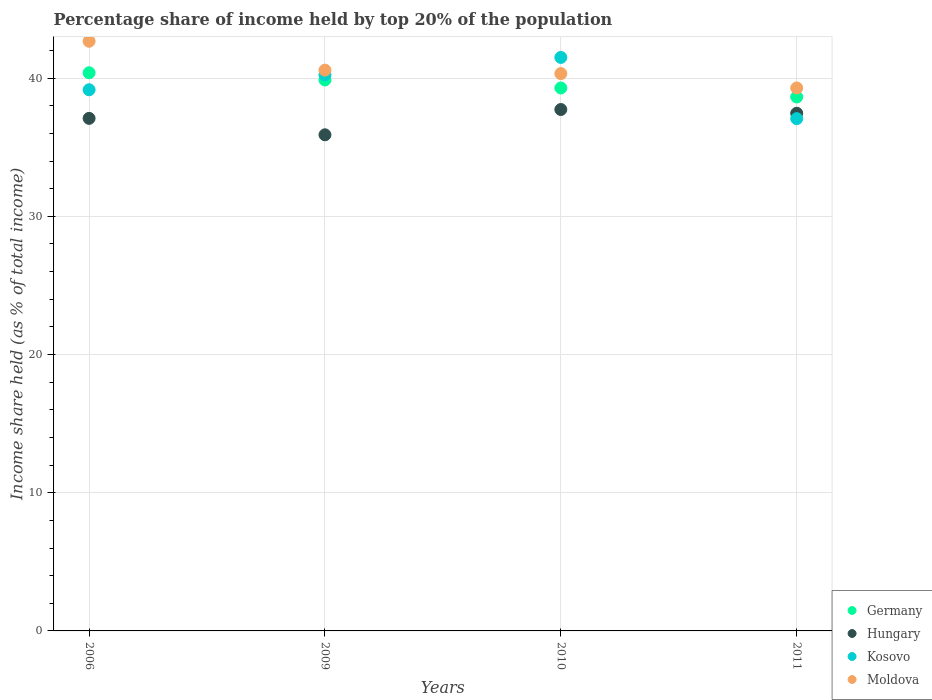Is the number of dotlines equal to the number of legend labels?
Your response must be concise. Yes. What is the percentage share of income held by top 20% of the population in Moldova in 2006?
Ensure brevity in your answer.  42.67. Across all years, what is the maximum percentage share of income held by top 20% of the population in Kosovo?
Provide a short and direct response. 41.5. Across all years, what is the minimum percentage share of income held by top 20% of the population in Germany?
Your answer should be very brief. 38.64. In which year was the percentage share of income held by top 20% of the population in Hungary maximum?
Offer a very short reply. 2010. What is the total percentage share of income held by top 20% of the population in Moldova in the graph?
Ensure brevity in your answer.  162.87. What is the difference between the percentage share of income held by top 20% of the population in Moldova in 2010 and that in 2011?
Provide a succinct answer. 1.04. What is the difference between the percentage share of income held by top 20% of the population in Germany in 2011 and the percentage share of income held by top 20% of the population in Hungary in 2010?
Offer a very short reply. 0.91. What is the average percentage share of income held by top 20% of the population in Moldova per year?
Your answer should be very brief. 40.72. In the year 2011, what is the difference between the percentage share of income held by top 20% of the population in Moldova and percentage share of income held by top 20% of the population in Kosovo?
Offer a very short reply. 2.22. In how many years, is the percentage share of income held by top 20% of the population in Hungary greater than 8 %?
Provide a succinct answer. 4. What is the ratio of the percentage share of income held by top 20% of the population in Germany in 2010 to that in 2011?
Offer a terse response. 1.02. What is the difference between the highest and the second highest percentage share of income held by top 20% of the population in Germany?
Your answer should be very brief. 0.52. Is it the case that in every year, the sum of the percentage share of income held by top 20% of the population in Hungary and percentage share of income held by top 20% of the population in Germany  is greater than the sum of percentage share of income held by top 20% of the population in Moldova and percentage share of income held by top 20% of the population in Kosovo?
Your answer should be compact. No. Is the percentage share of income held by top 20% of the population in Kosovo strictly less than the percentage share of income held by top 20% of the population in Moldova over the years?
Ensure brevity in your answer.  No. How many dotlines are there?
Offer a very short reply. 4. How many years are there in the graph?
Make the answer very short. 4. Does the graph contain any zero values?
Make the answer very short. No. Does the graph contain grids?
Provide a succinct answer. Yes. How many legend labels are there?
Keep it short and to the point. 4. What is the title of the graph?
Your answer should be very brief. Percentage share of income held by top 20% of the population. Does "Sri Lanka" appear as one of the legend labels in the graph?
Your answer should be very brief. No. What is the label or title of the Y-axis?
Offer a terse response. Income share held (as % of total income). What is the Income share held (as % of total income) in Germany in 2006?
Offer a very short reply. 40.39. What is the Income share held (as % of total income) in Hungary in 2006?
Your answer should be very brief. 37.09. What is the Income share held (as % of total income) of Kosovo in 2006?
Make the answer very short. 39.16. What is the Income share held (as % of total income) of Moldova in 2006?
Offer a very short reply. 42.67. What is the Income share held (as % of total income) of Germany in 2009?
Offer a very short reply. 39.87. What is the Income share held (as % of total income) of Hungary in 2009?
Ensure brevity in your answer.  35.9. What is the Income share held (as % of total income) of Kosovo in 2009?
Provide a short and direct response. 40.24. What is the Income share held (as % of total income) in Moldova in 2009?
Make the answer very short. 40.58. What is the Income share held (as % of total income) of Germany in 2010?
Give a very brief answer. 39.29. What is the Income share held (as % of total income) of Hungary in 2010?
Ensure brevity in your answer.  37.73. What is the Income share held (as % of total income) of Kosovo in 2010?
Provide a succinct answer. 41.5. What is the Income share held (as % of total income) of Moldova in 2010?
Offer a terse response. 40.33. What is the Income share held (as % of total income) in Germany in 2011?
Your answer should be compact. 38.64. What is the Income share held (as % of total income) in Hungary in 2011?
Provide a succinct answer. 37.46. What is the Income share held (as % of total income) in Kosovo in 2011?
Offer a terse response. 37.07. What is the Income share held (as % of total income) in Moldova in 2011?
Offer a very short reply. 39.29. Across all years, what is the maximum Income share held (as % of total income) of Germany?
Keep it short and to the point. 40.39. Across all years, what is the maximum Income share held (as % of total income) in Hungary?
Offer a terse response. 37.73. Across all years, what is the maximum Income share held (as % of total income) of Kosovo?
Your response must be concise. 41.5. Across all years, what is the maximum Income share held (as % of total income) of Moldova?
Give a very brief answer. 42.67. Across all years, what is the minimum Income share held (as % of total income) in Germany?
Make the answer very short. 38.64. Across all years, what is the minimum Income share held (as % of total income) in Hungary?
Your response must be concise. 35.9. Across all years, what is the minimum Income share held (as % of total income) of Kosovo?
Offer a very short reply. 37.07. Across all years, what is the minimum Income share held (as % of total income) in Moldova?
Make the answer very short. 39.29. What is the total Income share held (as % of total income) in Germany in the graph?
Offer a terse response. 158.19. What is the total Income share held (as % of total income) in Hungary in the graph?
Offer a very short reply. 148.18. What is the total Income share held (as % of total income) of Kosovo in the graph?
Provide a succinct answer. 157.97. What is the total Income share held (as % of total income) of Moldova in the graph?
Give a very brief answer. 162.87. What is the difference between the Income share held (as % of total income) in Germany in 2006 and that in 2009?
Make the answer very short. 0.52. What is the difference between the Income share held (as % of total income) in Hungary in 2006 and that in 2009?
Your answer should be very brief. 1.19. What is the difference between the Income share held (as % of total income) of Kosovo in 2006 and that in 2009?
Your answer should be compact. -1.08. What is the difference between the Income share held (as % of total income) of Moldova in 2006 and that in 2009?
Your answer should be very brief. 2.09. What is the difference between the Income share held (as % of total income) in Hungary in 2006 and that in 2010?
Provide a short and direct response. -0.64. What is the difference between the Income share held (as % of total income) in Kosovo in 2006 and that in 2010?
Make the answer very short. -2.34. What is the difference between the Income share held (as % of total income) in Moldova in 2006 and that in 2010?
Your answer should be very brief. 2.34. What is the difference between the Income share held (as % of total income) of Hungary in 2006 and that in 2011?
Provide a short and direct response. -0.37. What is the difference between the Income share held (as % of total income) in Kosovo in 2006 and that in 2011?
Keep it short and to the point. 2.09. What is the difference between the Income share held (as % of total income) in Moldova in 2006 and that in 2011?
Your answer should be compact. 3.38. What is the difference between the Income share held (as % of total income) of Germany in 2009 and that in 2010?
Give a very brief answer. 0.58. What is the difference between the Income share held (as % of total income) in Hungary in 2009 and that in 2010?
Your response must be concise. -1.83. What is the difference between the Income share held (as % of total income) in Kosovo in 2009 and that in 2010?
Your answer should be very brief. -1.26. What is the difference between the Income share held (as % of total income) of Germany in 2009 and that in 2011?
Your answer should be very brief. 1.23. What is the difference between the Income share held (as % of total income) in Hungary in 2009 and that in 2011?
Your response must be concise. -1.56. What is the difference between the Income share held (as % of total income) in Kosovo in 2009 and that in 2011?
Ensure brevity in your answer.  3.17. What is the difference between the Income share held (as % of total income) in Moldova in 2009 and that in 2011?
Give a very brief answer. 1.29. What is the difference between the Income share held (as % of total income) of Germany in 2010 and that in 2011?
Provide a succinct answer. 0.65. What is the difference between the Income share held (as % of total income) in Hungary in 2010 and that in 2011?
Give a very brief answer. 0.27. What is the difference between the Income share held (as % of total income) of Kosovo in 2010 and that in 2011?
Ensure brevity in your answer.  4.43. What is the difference between the Income share held (as % of total income) of Moldova in 2010 and that in 2011?
Your response must be concise. 1.04. What is the difference between the Income share held (as % of total income) of Germany in 2006 and the Income share held (as % of total income) of Hungary in 2009?
Your answer should be very brief. 4.49. What is the difference between the Income share held (as % of total income) in Germany in 2006 and the Income share held (as % of total income) in Moldova in 2009?
Your answer should be very brief. -0.19. What is the difference between the Income share held (as % of total income) in Hungary in 2006 and the Income share held (as % of total income) in Kosovo in 2009?
Your answer should be compact. -3.15. What is the difference between the Income share held (as % of total income) of Hungary in 2006 and the Income share held (as % of total income) of Moldova in 2009?
Your response must be concise. -3.49. What is the difference between the Income share held (as % of total income) in Kosovo in 2006 and the Income share held (as % of total income) in Moldova in 2009?
Ensure brevity in your answer.  -1.42. What is the difference between the Income share held (as % of total income) of Germany in 2006 and the Income share held (as % of total income) of Hungary in 2010?
Offer a very short reply. 2.66. What is the difference between the Income share held (as % of total income) of Germany in 2006 and the Income share held (as % of total income) of Kosovo in 2010?
Give a very brief answer. -1.11. What is the difference between the Income share held (as % of total income) in Hungary in 2006 and the Income share held (as % of total income) in Kosovo in 2010?
Offer a very short reply. -4.41. What is the difference between the Income share held (as % of total income) of Hungary in 2006 and the Income share held (as % of total income) of Moldova in 2010?
Your answer should be compact. -3.24. What is the difference between the Income share held (as % of total income) in Kosovo in 2006 and the Income share held (as % of total income) in Moldova in 2010?
Your answer should be compact. -1.17. What is the difference between the Income share held (as % of total income) in Germany in 2006 and the Income share held (as % of total income) in Hungary in 2011?
Your answer should be very brief. 2.93. What is the difference between the Income share held (as % of total income) of Germany in 2006 and the Income share held (as % of total income) of Kosovo in 2011?
Give a very brief answer. 3.32. What is the difference between the Income share held (as % of total income) in Kosovo in 2006 and the Income share held (as % of total income) in Moldova in 2011?
Your response must be concise. -0.13. What is the difference between the Income share held (as % of total income) in Germany in 2009 and the Income share held (as % of total income) in Hungary in 2010?
Keep it short and to the point. 2.14. What is the difference between the Income share held (as % of total income) in Germany in 2009 and the Income share held (as % of total income) in Kosovo in 2010?
Your answer should be very brief. -1.63. What is the difference between the Income share held (as % of total income) in Germany in 2009 and the Income share held (as % of total income) in Moldova in 2010?
Offer a very short reply. -0.46. What is the difference between the Income share held (as % of total income) of Hungary in 2009 and the Income share held (as % of total income) of Kosovo in 2010?
Your response must be concise. -5.6. What is the difference between the Income share held (as % of total income) of Hungary in 2009 and the Income share held (as % of total income) of Moldova in 2010?
Your answer should be compact. -4.43. What is the difference between the Income share held (as % of total income) of Kosovo in 2009 and the Income share held (as % of total income) of Moldova in 2010?
Your answer should be compact. -0.09. What is the difference between the Income share held (as % of total income) in Germany in 2009 and the Income share held (as % of total income) in Hungary in 2011?
Your answer should be very brief. 2.41. What is the difference between the Income share held (as % of total income) of Germany in 2009 and the Income share held (as % of total income) of Moldova in 2011?
Your answer should be compact. 0.58. What is the difference between the Income share held (as % of total income) of Hungary in 2009 and the Income share held (as % of total income) of Kosovo in 2011?
Provide a succinct answer. -1.17. What is the difference between the Income share held (as % of total income) in Hungary in 2009 and the Income share held (as % of total income) in Moldova in 2011?
Provide a succinct answer. -3.39. What is the difference between the Income share held (as % of total income) of Kosovo in 2009 and the Income share held (as % of total income) of Moldova in 2011?
Offer a terse response. 0.95. What is the difference between the Income share held (as % of total income) in Germany in 2010 and the Income share held (as % of total income) in Hungary in 2011?
Provide a succinct answer. 1.83. What is the difference between the Income share held (as % of total income) of Germany in 2010 and the Income share held (as % of total income) of Kosovo in 2011?
Give a very brief answer. 2.22. What is the difference between the Income share held (as % of total income) of Hungary in 2010 and the Income share held (as % of total income) of Kosovo in 2011?
Make the answer very short. 0.66. What is the difference between the Income share held (as % of total income) of Hungary in 2010 and the Income share held (as % of total income) of Moldova in 2011?
Ensure brevity in your answer.  -1.56. What is the difference between the Income share held (as % of total income) in Kosovo in 2010 and the Income share held (as % of total income) in Moldova in 2011?
Make the answer very short. 2.21. What is the average Income share held (as % of total income) in Germany per year?
Give a very brief answer. 39.55. What is the average Income share held (as % of total income) of Hungary per year?
Give a very brief answer. 37.05. What is the average Income share held (as % of total income) in Kosovo per year?
Make the answer very short. 39.49. What is the average Income share held (as % of total income) of Moldova per year?
Give a very brief answer. 40.72. In the year 2006, what is the difference between the Income share held (as % of total income) in Germany and Income share held (as % of total income) in Kosovo?
Offer a very short reply. 1.23. In the year 2006, what is the difference between the Income share held (as % of total income) in Germany and Income share held (as % of total income) in Moldova?
Make the answer very short. -2.28. In the year 2006, what is the difference between the Income share held (as % of total income) in Hungary and Income share held (as % of total income) in Kosovo?
Give a very brief answer. -2.07. In the year 2006, what is the difference between the Income share held (as % of total income) in Hungary and Income share held (as % of total income) in Moldova?
Give a very brief answer. -5.58. In the year 2006, what is the difference between the Income share held (as % of total income) in Kosovo and Income share held (as % of total income) in Moldova?
Provide a short and direct response. -3.51. In the year 2009, what is the difference between the Income share held (as % of total income) in Germany and Income share held (as % of total income) in Hungary?
Make the answer very short. 3.97. In the year 2009, what is the difference between the Income share held (as % of total income) in Germany and Income share held (as % of total income) in Kosovo?
Provide a short and direct response. -0.37. In the year 2009, what is the difference between the Income share held (as % of total income) in Germany and Income share held (as % of total income) in Moldova?
Provide a succinct answer. -0.71. In the year 2009, what is the difference between the Income share held (as % of total income) of Hungary and Income share held (as % of total income) of Kosovo?
Provide a succinct answer. -4.34. In the year 2009, what is the difference between the Income share held (as % of total income) in Hungary and Income share held (as % of total income) in Moldova?
Offer a terse response. -4.68. In the year 2009, what is the difference between the Income share held (as % of total income) of Kosovo and Income share held (as % of total income) of Moldova?
Ensure brevity in your answer.  -0.34. In the year 2010, what is the difference between the Income share held (as % of total income) in Germany and Income share held (as % of total income) in Hungary?
Provide a succinct answer. 1.56. In the year 2010, what is the difference between the Income share held (as % of total income) in Germany and Income share held (as % of total income) in Kosovo?
Keep it short and to the point. -2.21. In the year 2010, what is the difference between the Income share held (as % of total income) of Germany and Income share held (as % of total income) of Moldova?
Provide a short and direct response. -1.04. In the year 2010, what is the difference between the Income share held (as % of total income) of Hungary and Income share held (as % of total income) of Kosovo?
Provide a succinct answer. -3.77. In the year 2010, what is the difference between the Income share held (as % of total income) in Hungary and Income share held (as % of total income) in Moldova?
Your answer should be compact. -2.6. In the year 2010, what is the difference between the Income share held (as % of total income) of Kosovo and Income share held (as % of total income) of Moldova?
Ensure brevity in your answer.  1.17. In the year 2011, what is the difference between the Income share held (as % of total income) in Germany and Income share held (as % of total income) in Hungary?
Your answer should be compact. 1.18. In the year 2011, what is the difference between the Income share held (as % of total income) of Germany and Income share held (as % of total income) of Kosovo?
Offer a very short reply. 1.57. In the year 2011, what is the difference between the Income share held (as % of total income) in Germany and Income share held (as % of total income) in Moldova?
Provide a succinct answer. -0.65. In the year 2011, what is the difference between the Income share held (as % of total income) in Hungary and Income share held (as % of total income) in Kosovo?
Provide a succinct answer. 0.39. In the year 2011, what is the difference between the Income share held (as % of total income) in Hungary and Income share held (as % of total income) in Moldova?
Ensure brevity in your answer.  -1.83. In the year 2011, what is the difference between the Income share held (as % of total income) in Kosovo and Income share held (as % of total income) in Moldova?
Offer a terse response. -2.22. What is the ratio of the Income share held (as % of total income) in Germany in 2006 to that in 2009?
Offer a terse response. 1.01. What is the ratio of the Income share held (as % of total income) of Hungary in 2006 to that in 2009?
Provide a short and direct response. 1.03. What is the ratio of the Income share held (as % of total income) in Kosovo in 2006 to that in 2009?
Provide a succinct answer. 0.97. What is the ratio of the Income share held (as % of total income) in Moldova in 2006 to that in 2009?
Offer a terse response. 1.05. What is the ratio of the Income share held (as % of total income) of Germany in 2006 to that in 2010?
Your answer should be very brief. 1.03. What is the ratio of the Income share held (as % of total income) of Kosovo in 2006 to that in 2010?
Provide a succinct answer. 0.94. What is the ratio of the Income share held (as % of total income) in Moldova in 2006 to that in 2010?
Ensure brevity in your answer.  1.06. What is the ratio of the Income share held (as % of total income) in Germany in 2006 to that in 2011?
Ensure brevity in your answer.  1.05. What is the ratio of the Income share held (as % of total income) in Kosovo in 2006 to that in 2011?
Give a very brief answer. 1.06. What is the ratio of the Income share held (as % of total income) of Moldova in 2006 to that in 2011?
Provide a succinct answer. 1.09. What is the ratio of the Income share held (as % of total income) in Germany in 2009 to that in 2010?
Offer a terse response. 1.01. What is the ratio of the Income share held (as % of total income) of Hungary in 2009 to that in 2010?
Give a very brief answer. 0.95. What is the ratio of the Income share held (as % of total income) in Kosovo in 2009 to that in 2010?
Give a very brief answer. 0.97. What is the ratio of the Income share held (as % of total income) of Moldova in 2009 to that in 2010?
Give a very brief answer. 1.01. What is the ratio of the Income share held (as % of total income) of Germany in 2009 to that in 2011?
Offer a very short reply. 1.03. What is the ratio of the Income share held (as % of total income) of Hungary in 2009 to that in 2011?
Provide a succinct answer. 0.96. What is the ratio of the Income share held (as % of total income) in Kosovo in 2009 to that in 2011?
Offer a terse response. 1.09. What is the ratio of the Income share held (as % of total income) of Moldova in 2009 to that in 2011?
Offer a very short reply. 1.03. What is the ratio of the Income share held (as % of total income) of Germany in 2010 to that in 2011?
Your answer should be very brief. 1.02. What is the ratio of the Income share held (as % of total income) in Kosovo in 2010 to that in 2011?
Your answer should be very brief. 1.12. What is the ratio of the Income share held (as % of total income) in Moldova in 2010 to that in 2011?
Keep it short and to the point. 1.03. What is the difference between the highest and the second highest Income share held (as % of total income) of Germany?
Keep it short and to the point. 0.52. What is the difference between the highest and the second highest Income share held (as % of total income) in Hungary?
Keep it short and to the point. 0.27. What is the difference between the highest and the second highest Income share held (as % of total income) of Kosovo?
Offer a very short reply. 1.26. What is the difference between the highest and the second highest Income share held (as % of total income) of Moldova?
Your answer should be very brief. 2.09. What is the difference between the highest and the lowest Income share held (as % of total income) of Hungary?
Provide a short and direct response. 1.83. What is the difference between the highest and the lowest Income share held (as % of total income) in Kosovo?
Your answer should be compact. 4.43. What is the difference between the highest and the lowest Income share held (as % of total income) of Moldova?
Keep it short and to the point. 3.38. 